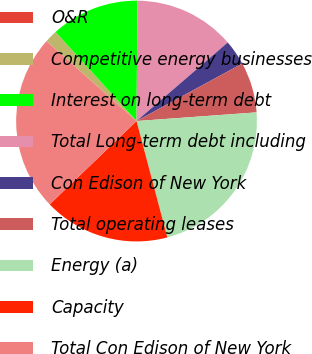Convert chart to OTSL. <chart><loc_0><loc_0><loc_500><loc_500><pie_chart><fcel>O&R<fcel>Competitive energy businesses<fcel>Interest on long-term debt<fcel>Total Long-term debt including<fcel>Con Edison of New York<fcel>Total operating leases<fcel>Energy (a)<fcel>Capacity<fcel>Total Con Edison of New York<nl><fcel>0.01%<fcel>1.7%<fcel>11.86%<fcel>13.56%<fcel>3.39%<fcel>6.78%<fcel>22.03%<fcel>16.95%<fcel>23.72%<nl></chart> 